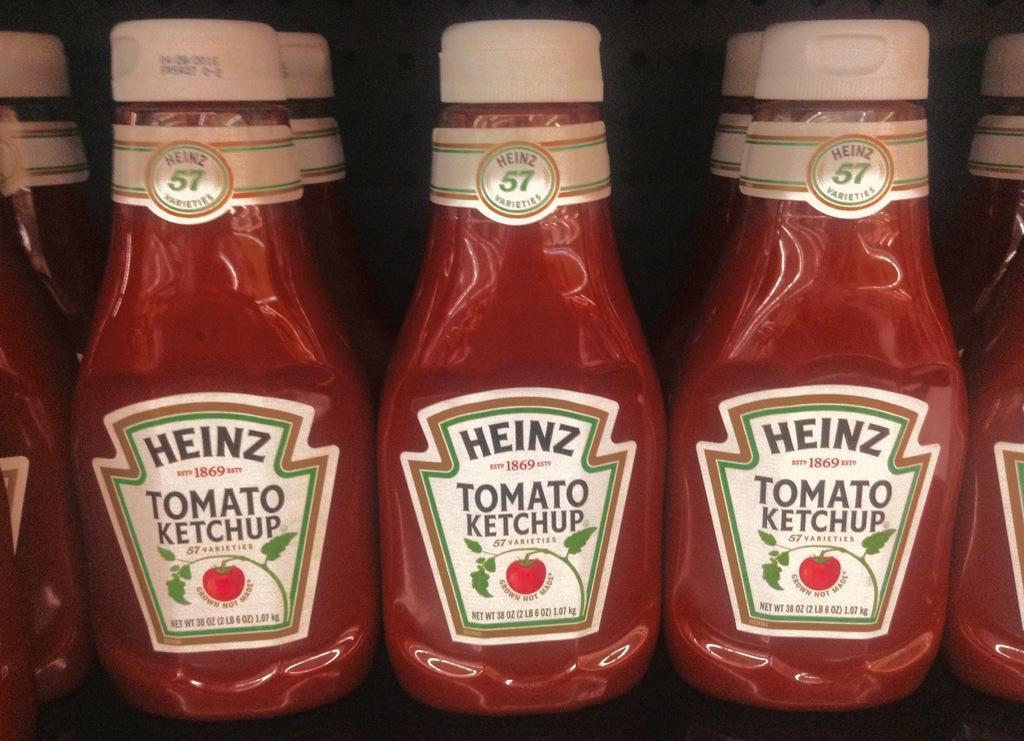Describe this image in one or two sentences. In this image I can see ketchup bottles arranged in an order. And there is a dark background. 